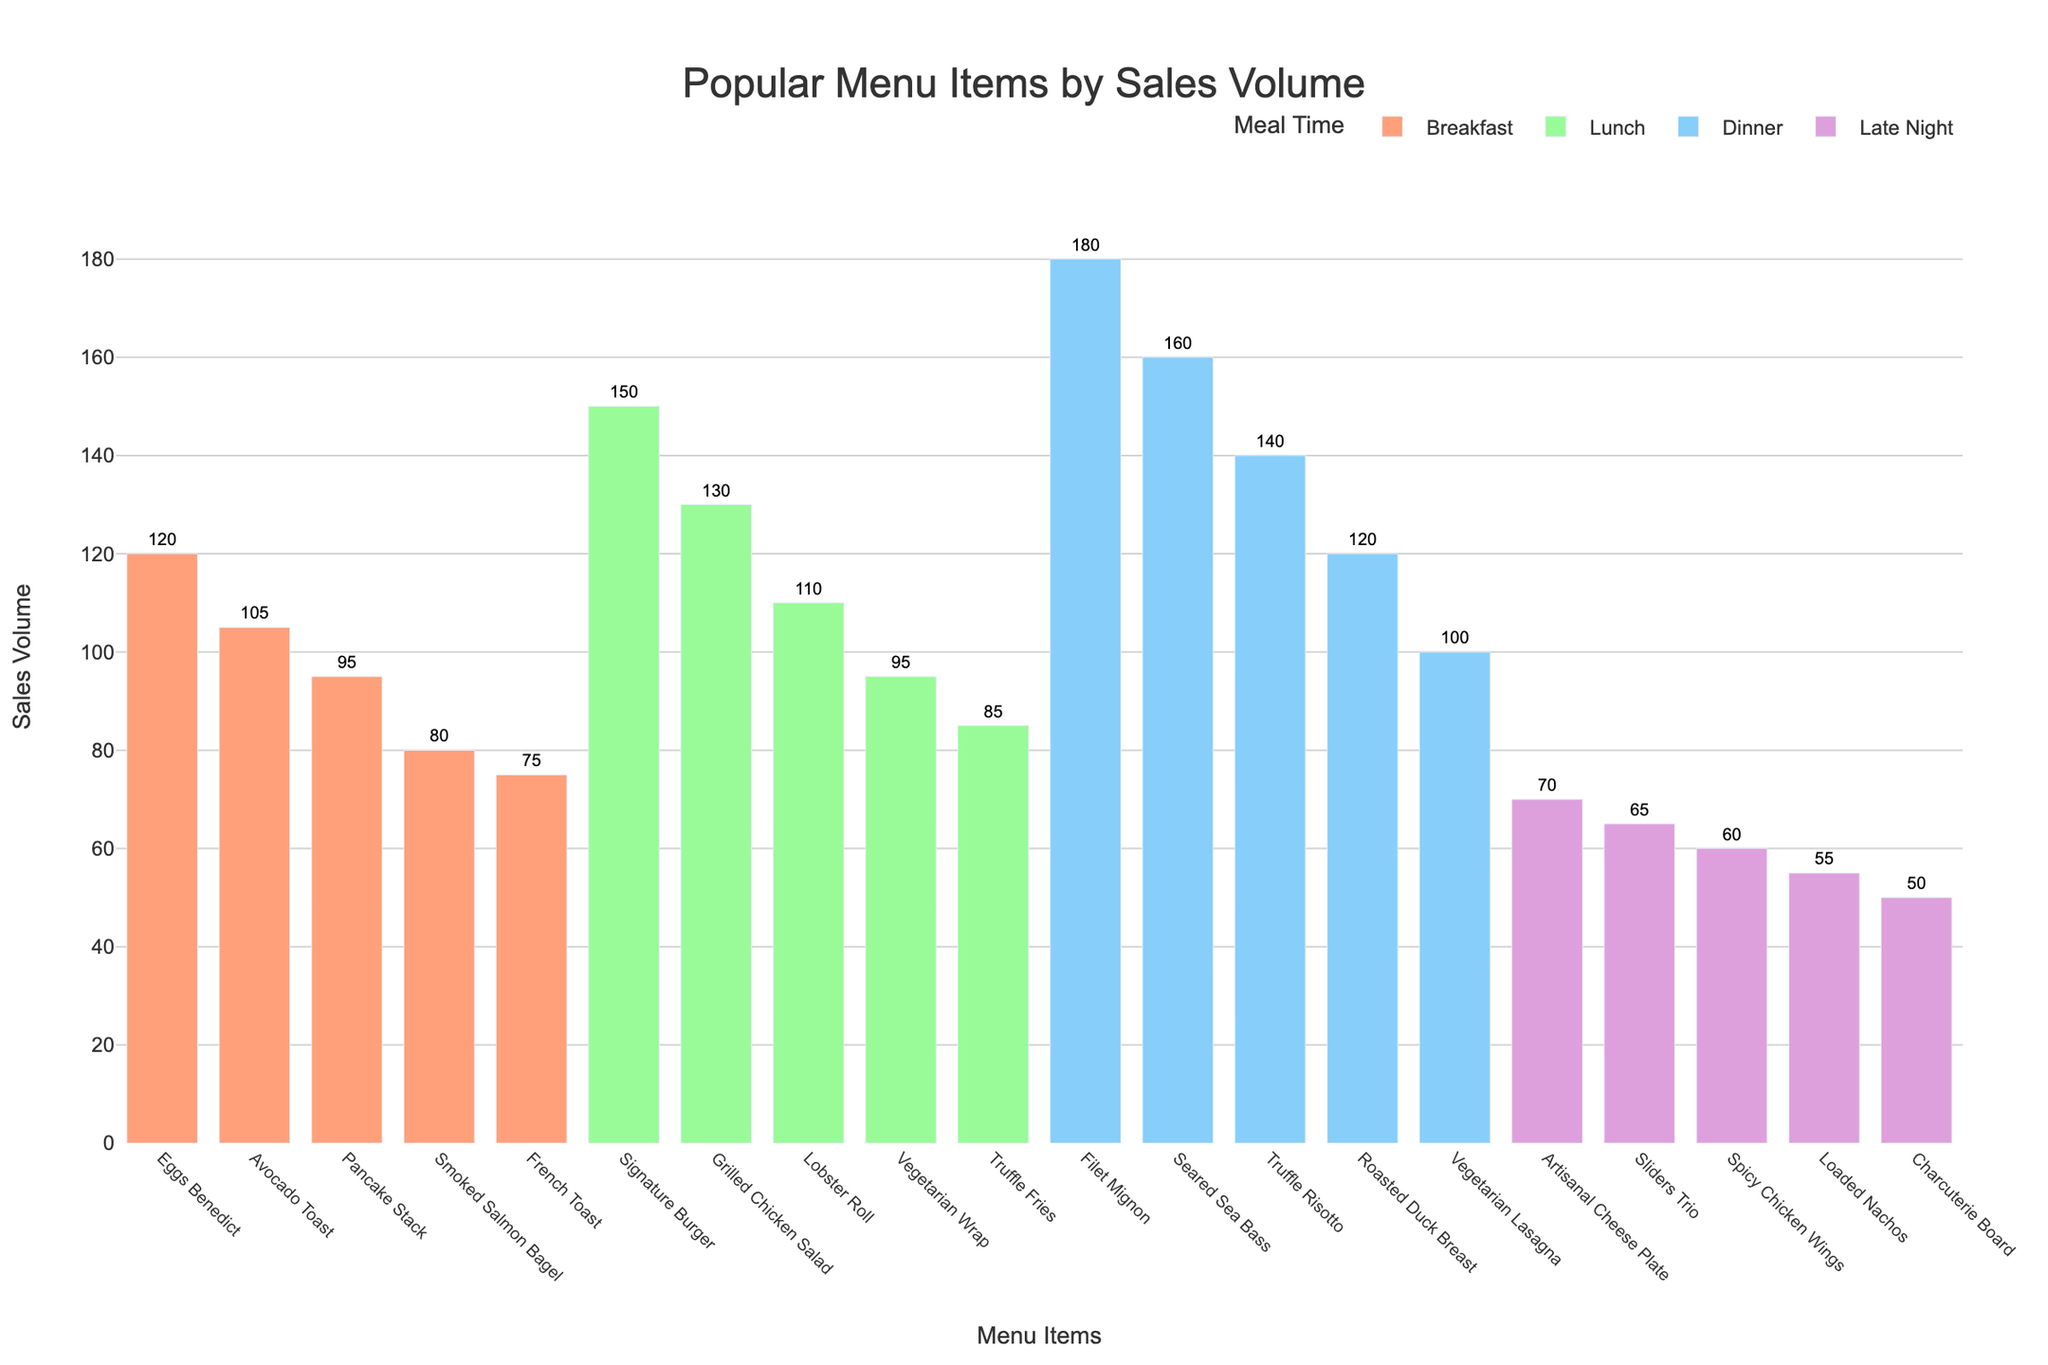What's the most popular menu item for dinner? Look at the bar labeled "Dinner" and find the tallest bar. The "Filet Mignon" has the highest sales volume among the dinner items at 180.
Answer: Filet Mignon Which meal time has the highest selling item overall? Compare the tallest bars from each meal time: Breakfast (Eggs Benedict - 120), Lunch (Signature Burger - 150), Dinner (Filet Mignon - 180), Late Night (Artisanal Cheese Plate - 70). The "Filet Mignon" from Dinner has the highest sales volume at 180.
Answer: Dinner What's the difference in sales volume between the most popular and least popular breakfast items? For breakfast, the most popular item is "Eggs Benedict" (120), and the least popular is "French Toast" (75). The difference is 120 - 75.
Answer: 45 What's the total sales volume for lunch items? Sum the sales volumes for lunch items: Signature Burger (150), Grilled Chicken Salad (130), Lobster Roll (110), Vegetarian Wrap (95), Truffle Fries (85). Total is 150 + 130 + 110 + 95 + 85.
Answer: 570 Among late night items, which menu item sells less than 60 units? Look at the bars for Late Night items, and find those with sales volumes less than 60. The "Charcuterie Board" at 50 units and "Loaded Nachos" at 55 units both sell less than 60 units.
Answer: Charcuterie Board, Loaded Nachos Which menu item is the least popular for dinner, and how does its sales volume compare to the most popular lunch item? The least popular dinner item is "Vegetarian Lasagna" with a sales volume of 100. The most popular lunch item is "Signature Burger" with 150. Compare their volumes: 150 - 100.
Answer: The Vegetarian Lasagna is 50 units less than the Signature Burger How many dinner items have a sales volume greater than 150? Check Dinner items and count those with sales volumes over 150. "Filet Mignon" (180) and "Seared Sea Bass" (160) meet this criterion, so there are 2 such items.
Answer: 2 Which is more popular: the top breakfast item or the second most popular dinner item? Compare "Eggs Benedict" (120, top breakfast item) with the second most popular dinner item, "Seared Sea Bass" (160).
Answer: Seared Sea Bass What is the average sales volume for the breakfast items? Sum the sales volumes for breakfast items: Eggs Benedict (120), Avocado Toast (105), Pancake Stack (95), Smoked Salmon Bagel (80), French Toast (75). Then divide by the number of items: (120 + 105 + 95 + 80 + 75) / 5.
Answer: 95 Summing all four highest selling items from each meal time, what is the total? Identify the highest item from each meal time: Breakfast (Eggs Benedict - 120), Lunch (Signature Burger - 150), Dinner (Filet Mignon - 180), Late Night (Artisanal Cheese Plate - 70). Add these together: 120 + 150 + 180 + 70.
Answer: 520 